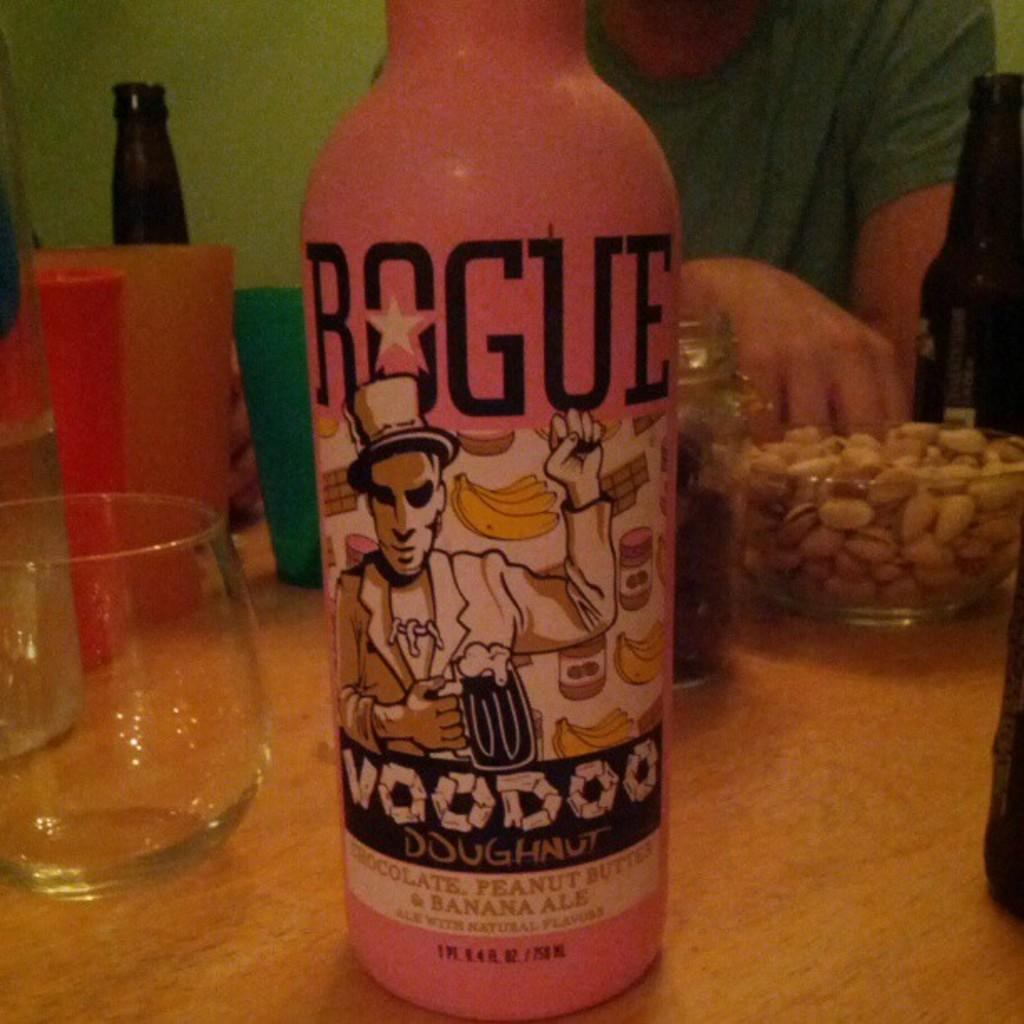<image>
Describe the image concisely. A bottle of voodoo ale is on a table. 